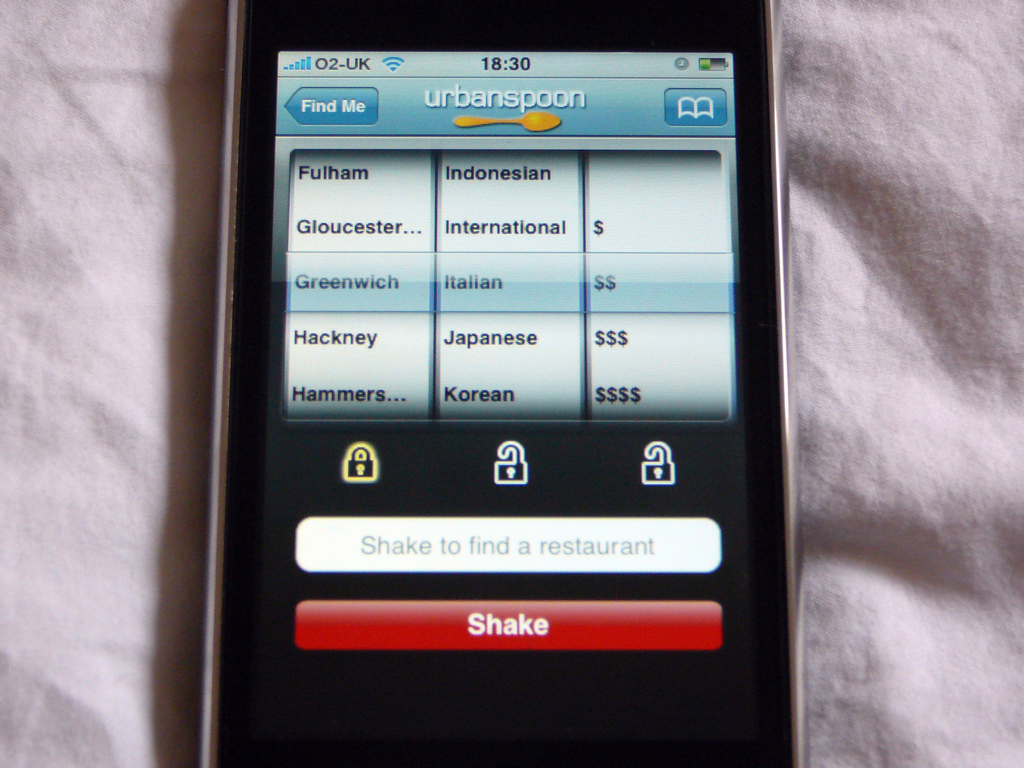What do you see happening in this image? The image depicts a mobile phone displaying the Urbanspoon app, which is an application used to find restaurants based on various filters such as location and cuisine type. In this particular screenshot, the app shows restaurant options for locations like Fulham and Greenwich, and cuisines ranging from Indonesian to Korean with associated pricing tiers. Notably, this app offers a unique feature where users can physically shake their phone to discover a randomly selected restaurant, adding a fun, interactive element to the dining decision process. The clock on the device reads 18:30 and the network provider is displayed as O2-UK, suggesting the user is in the United Kingdom during the evening, possibly looking for dinner options. 